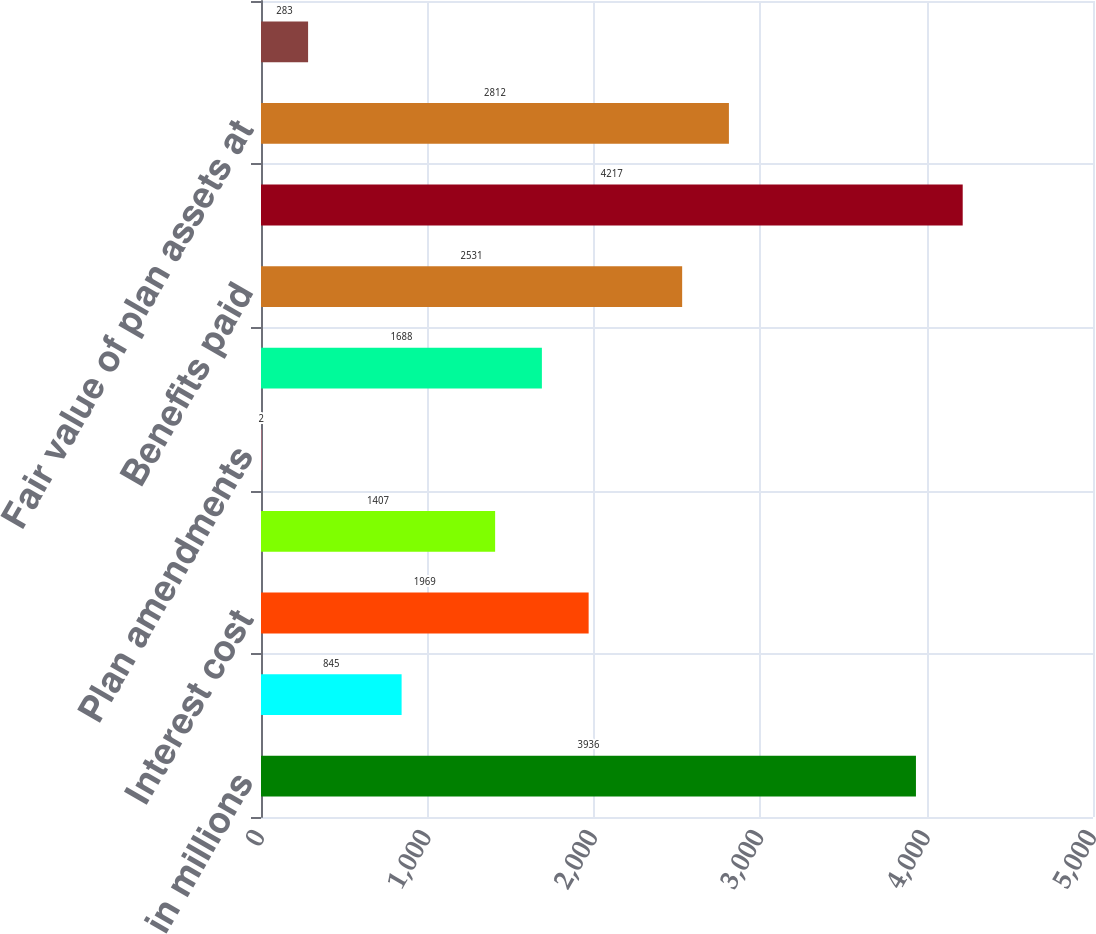Convert chart. <chart><loc_0><loc_0><loc_500><loc_500><bar_chart><fcel>in millions<fcel>Service cost<fcel>Interest cost<fcel>Plan participants'<fcel>Plan amendments<fcel>Actuarial gain<fcel>Benefits paid<fcel>Benefit obligation at end of<fcel>Fair value of plan assets at<fcel>(Loss) / Gain on plan assets<nl><fcel>3936<fcel>845<fcel>1969<fcel>1407<fcel>2<fcel>1688<fcel>2531<fcel>4217<fcel>2812<fcel>283<nl></chart> 